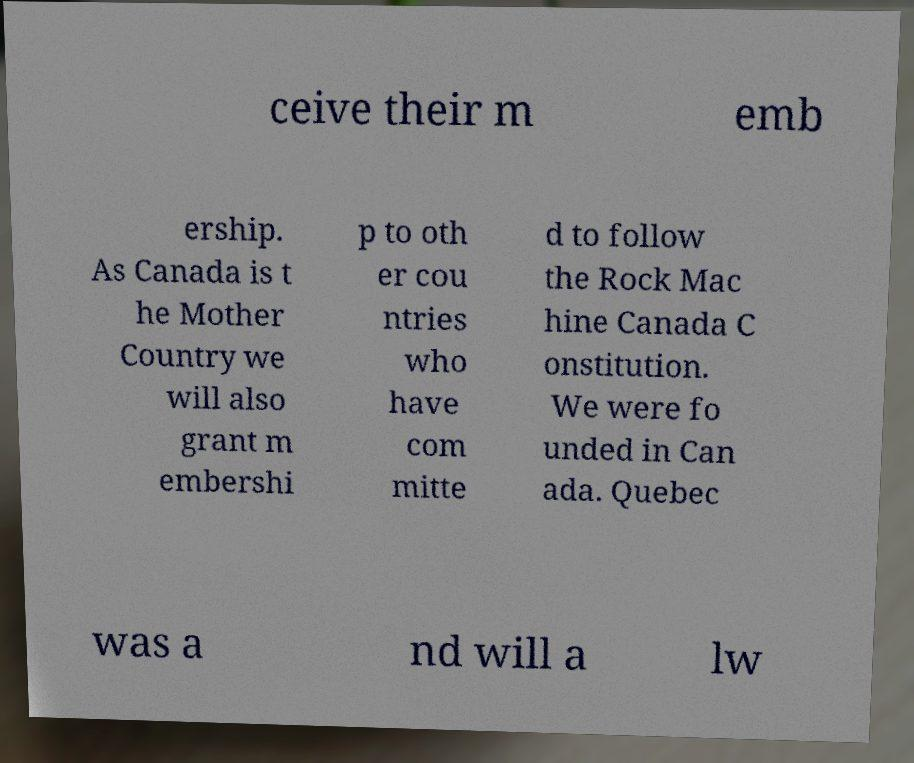Can you accurately transcribe the text from the provided image for me? ceive their m emb ership. As Canada is t he Mother Country we will also grant m embershi p to oth er cou ntries who have com mitte d to follow the Rock Mac hine Canada C onstitution. We were fo unded in Can ada. Quebec was a nd will a lw 